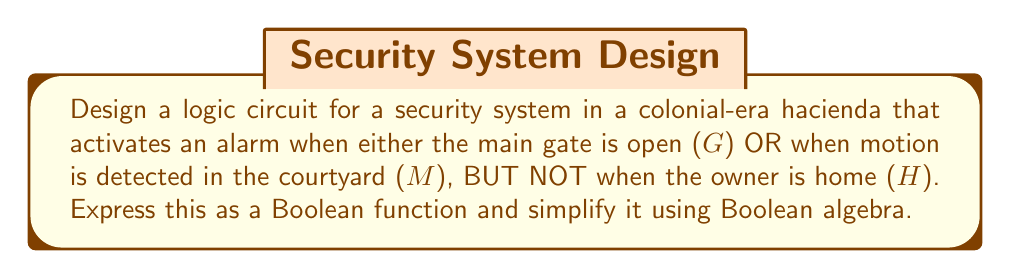Teach me how to tackle this problem. Let's approach this step-by-step:

1) First, we need to translate the requirements into a Boolean expression:
   - Alarm activates when the gate is open (G) OR motion is detected (M)
   - BUT NOT when the owner is home (H)

2) This can be expressed as: $$(G + M) \cdot \overline{H}$$

3) Let's expand this using the distributive law:
   $$(G + M) \cdot \overline{H} = (G \cdot \overline{H}) + (M \cdot \overline{H})$$

4) This expression is already in its simplest form, known as the sum-of-products (SOP) form.

5) To implement this as a logic circuit, we would need:
   - An OR gate for (G + M)
   - An inverter (NOT gate) for $\overline{H}$
   - Two AND gates for $(G \cdot \overline{H})$ and $(M \cdot \overline{H})$
   - A final OR gate to combine these two terms

6) The resulting circuit would activate the alarm when either:
   - The gate is open AND the owner is not home, OR
   - Motion is detected AND the owner is not home

This design ensures the security of the hacienda while allowing the owner to move freely when at home, much like how the patrones of old could enjoy their estates without constant interruptions.
Answer: $$(G \cdot \overline{H}) + (M \cdot \overline{H})$$ 